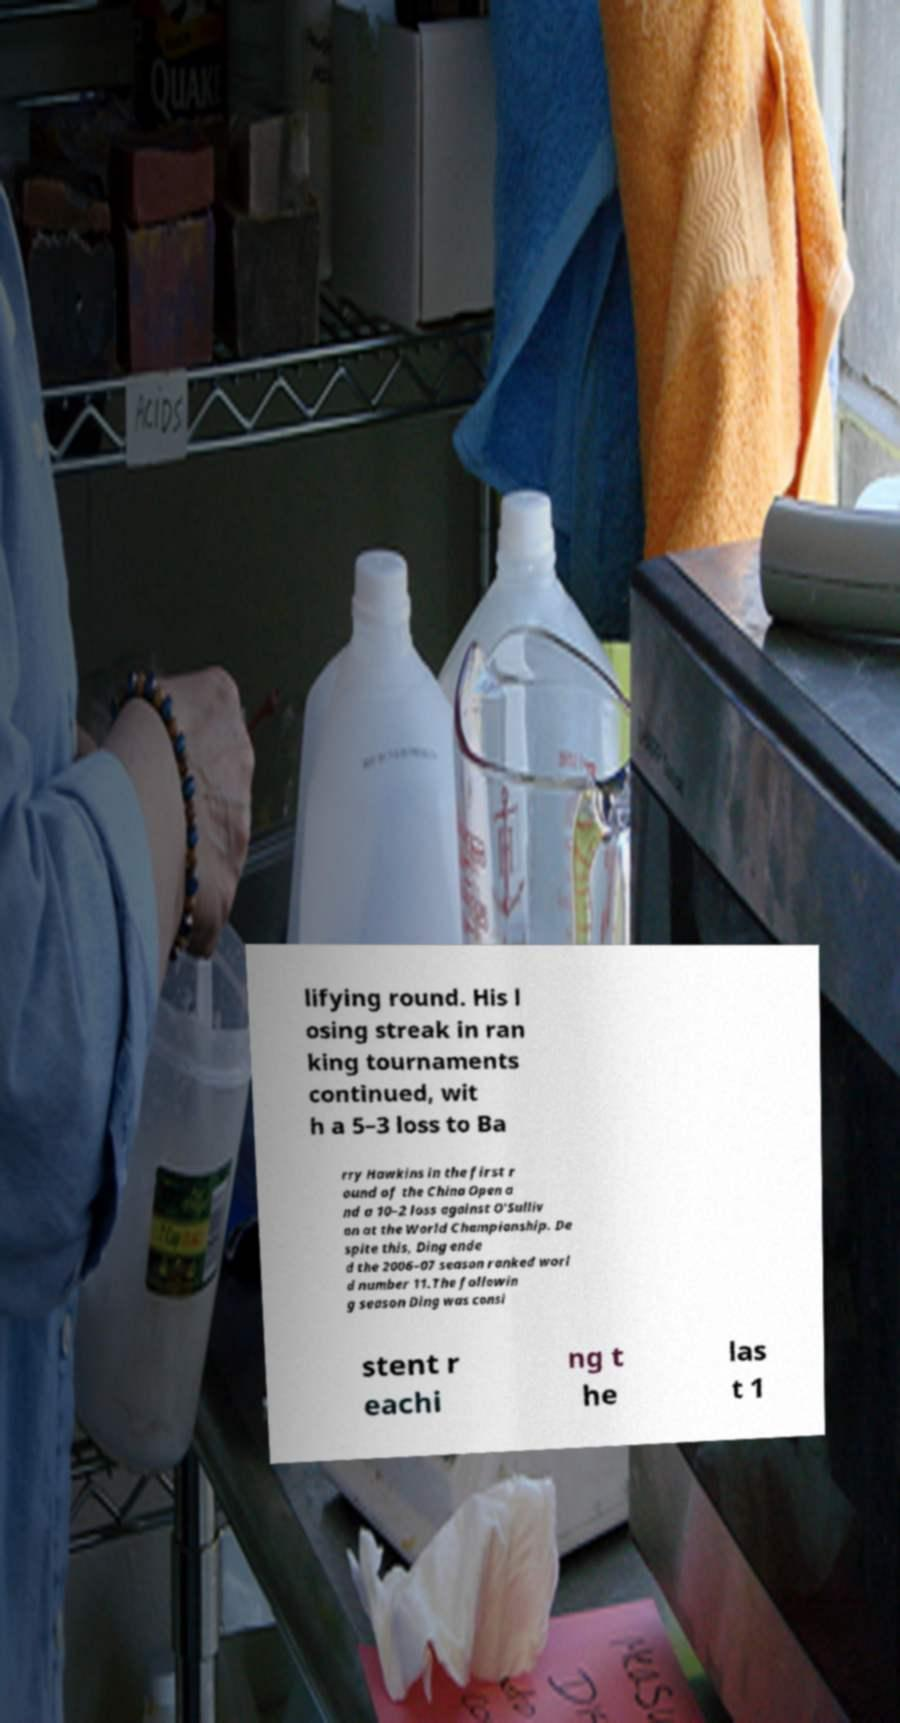Could you extract and type out the text from this image? lifying round. His l osing streak in ran king tournaments continued, wit h a 5–3 loss to Ba rry Hawkins in the first r ound of the China Open a nd a 10–2 loss against O'Sulliv an at the World Championship. De spite this, Ding ende d the 2006–07 season ranked worl d number 11.The followin g season Ding was consi stent r eachi ng t he las t 1 